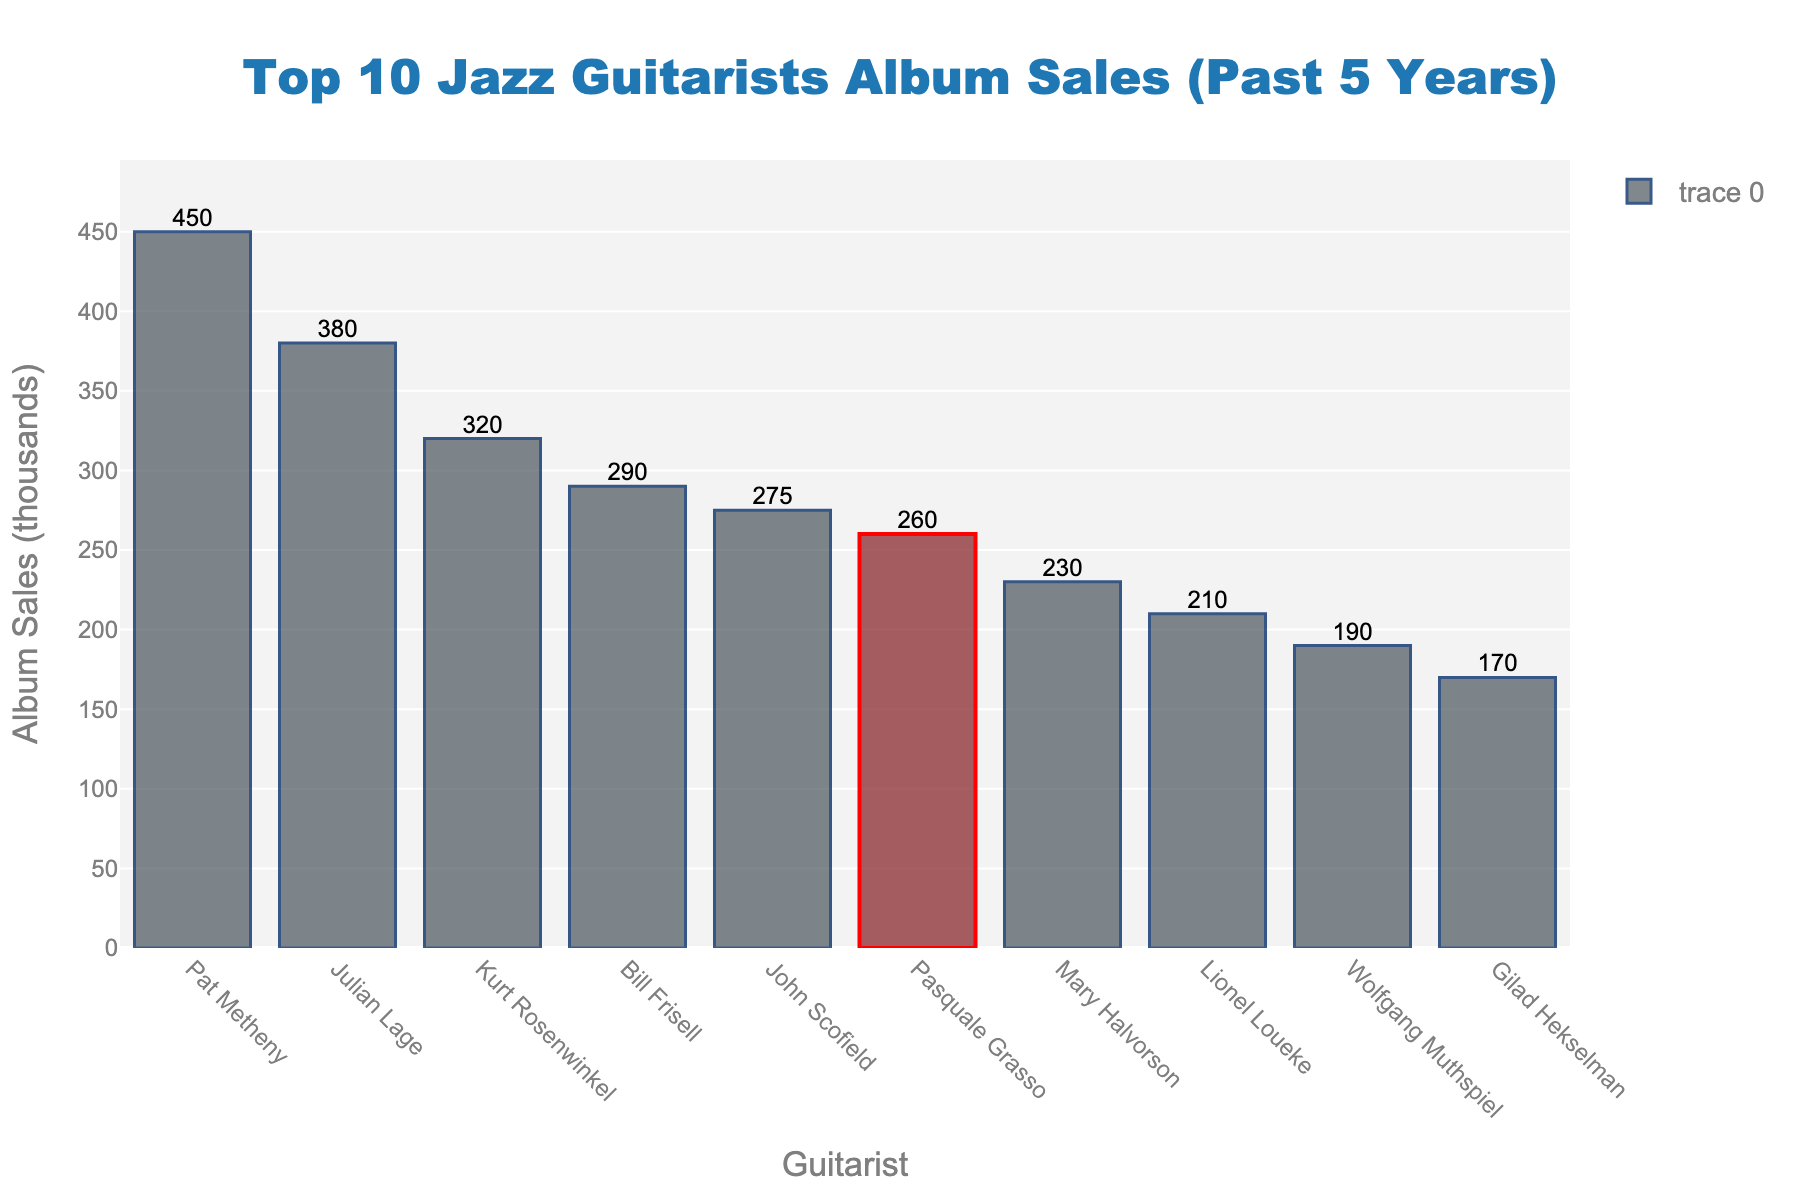What is the total number of album sales for the top 3 jazz guitarists? Pat Metheny sold 450,000 albums, Julian Lage sold 380,000, and Kurt Rosenwinkel sold 320,000. Adding these together gives 450 + 380 + 320 = 1150 thousand albums.
Answer: 1150 Who has higher album sales, Pasquale Grasso or Mary Halvorson? Pasquale Grasso has 260,000 album sales, while Mary Halvorson has 230,000. Pasquale Grasso's album sales are higher.
Answer: Pasquale Grasso What is the difference in album sales between the guitarist with the highest sales and the guitarist with the lowest sales? The guitarist with the highest sales is Pat Metheny with 450,000, and the one with the lowest sales is Gilad Hekselman with 170,000. The difference is 450 - 170 = 280 thousand albums.
Answer: 280 What is the average album sales of all ten guitarists? Total album sales are 450 + 380 + 320 + 290 + 275 + 260 + 230 + 210 + 190 + 170 = 2775 thousand albums. There are 10 guitarists, so the average is 2775 / 10 = 277.5 thousand albums.
Answer: 277.5 Which guitarist has just below Pasquale Grasso in terms of album sales? Mary Halvorson is directly below Pasquale Grasso in terms of album sales, with 230,000 albums sold compared to Pasquale's 260,000.
Answer: Mary Halvorson What is the sum of album sales of guitarists with sales less than 250,000? Those below 250,000 are Mary Halvorson (230,000), Lionel Loueke (210,000), Wolfgang Muthspiel (190,000), and Gilad Hekselman (170,000). Summing these: 230 + 210 + 190 + 170 = 800 thousand albums.
Answer: 800 How does Lionel Loueke's album sales compare visually to Pasquale Grasso's in the chart? Lionel Loueke's bar is shorter than Pasquale Grasso's bar, and Pasquale's bar is highlighted with a red border.
Answer: Shorter Who are the guitarists in the top 5 for album sales, and what are their combined sales? The top 5 are Pat Metheny (450,000), Julian Lage (380,000), Kurt Rosenwinkel (320,000), Bill Frisell (290,000), and John Scofield (275,000). Combined sales are 450 + 380 + 320 + 290 + 275 = 1715 thousand albums.
Answer: Pat Metheny, Julian Lage, Kurt Rosenwinkel, Bill Frisell, John Scofield; 1715 What are the album sales of the guitarist highlighted in red? The highlighted guitarist in red is Pasquale Grasso, and his album sales are 260,000.
Answer: 260 